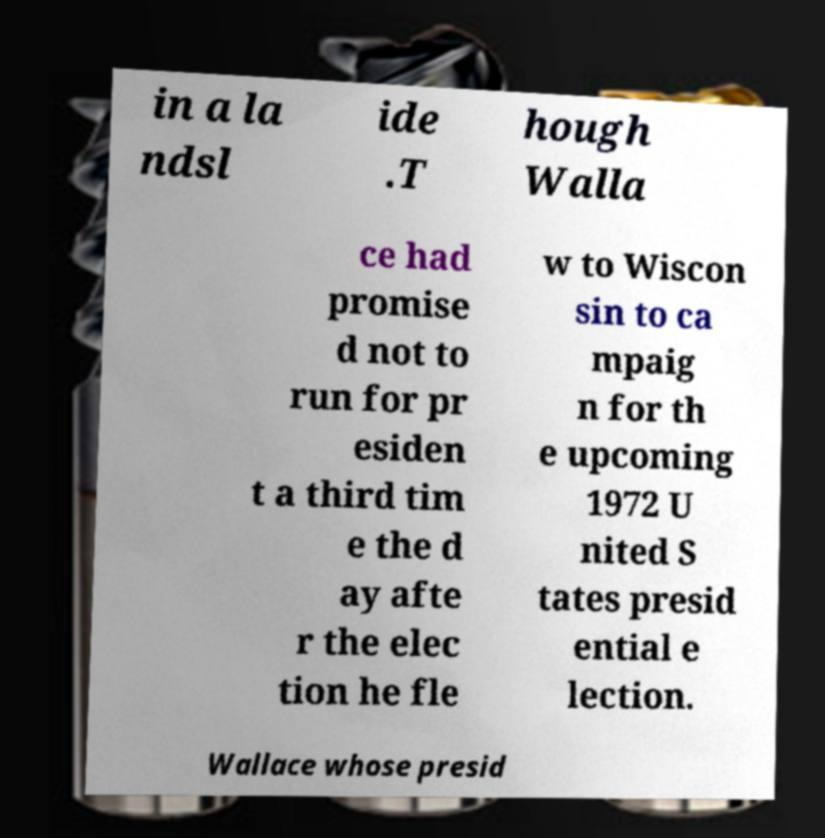There's text embedded in this image that I need extracted. Can you transcribe it verbatim? in a la ndsl ide .T hough Walla ce had promise d not to run for pr esiden t a third tim e the d ay afte r the elec tion he fle w to Wiscon sin to ca mpaig n for th e upcoming 1972 U nited S tates presid ential e lection. Wallace whose presid 